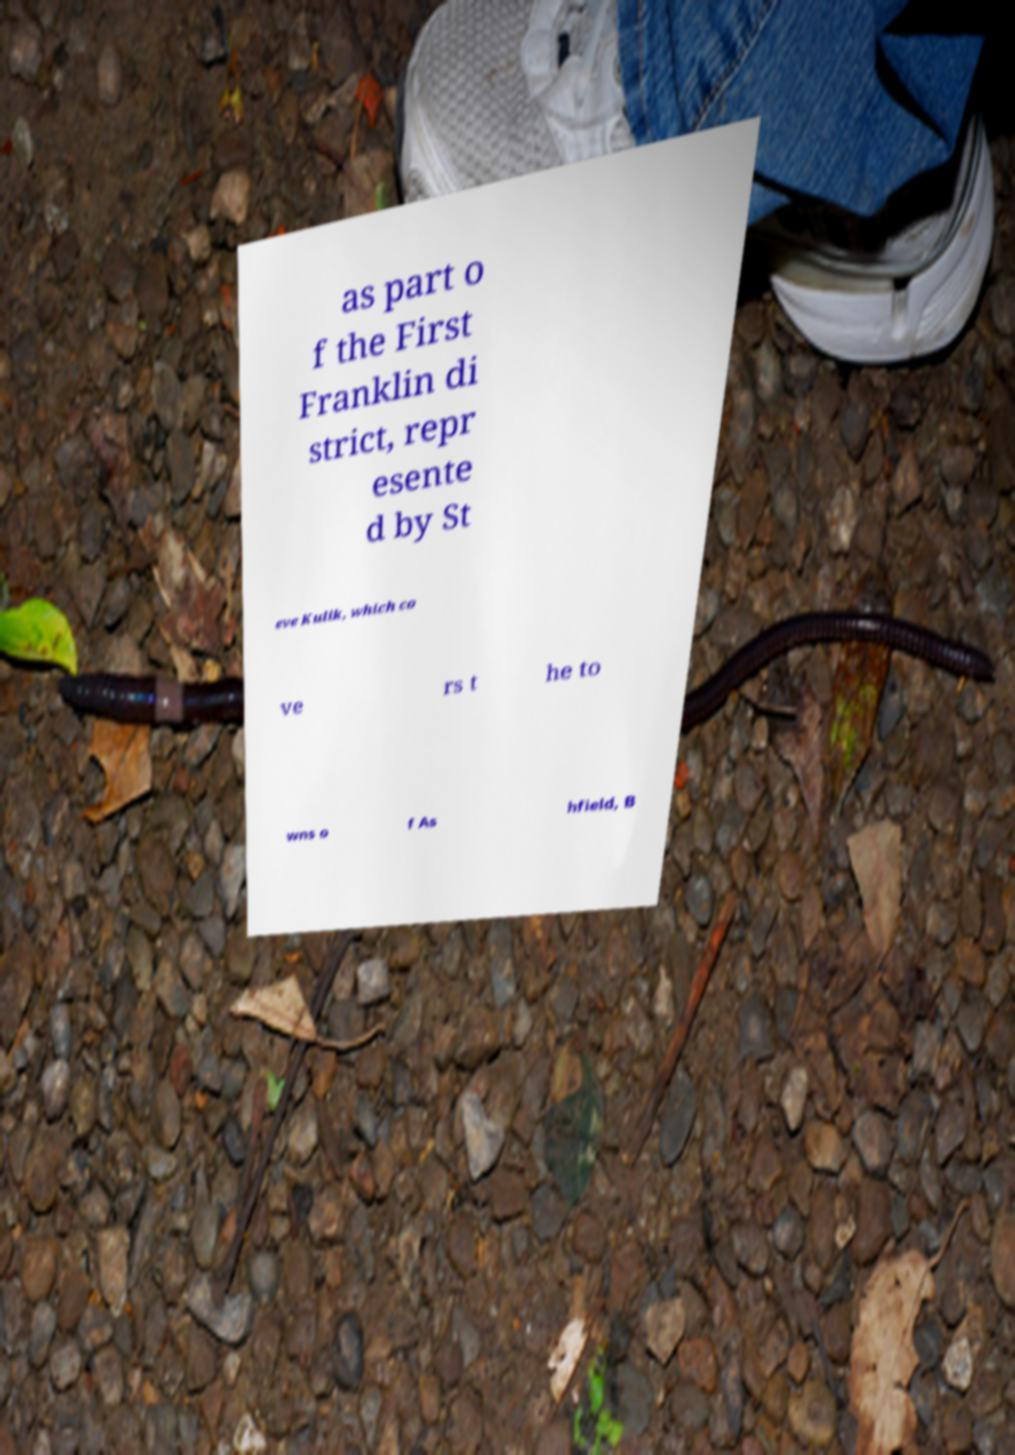Please read and relay the text visible in this image. What does it say? as part o f the First Franklin di strict, repr esente d by St eve Kulik, which co ve rs t he to wns o f As hfield, B 